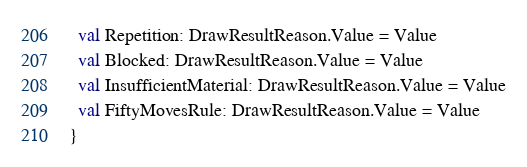Convert code to text. <code><loc_0><loc_0><loc_500><loc_500><_Scala_>  val Repetition: DrawResultReason.Value = Value
  val Blocked: DrawResultReason.Value = Value
  val InsufficientMaterial: DrawResultReason.Value = Value
  val FiftyMovesRule: DrawResultReason.Value = Value
}
</code> 